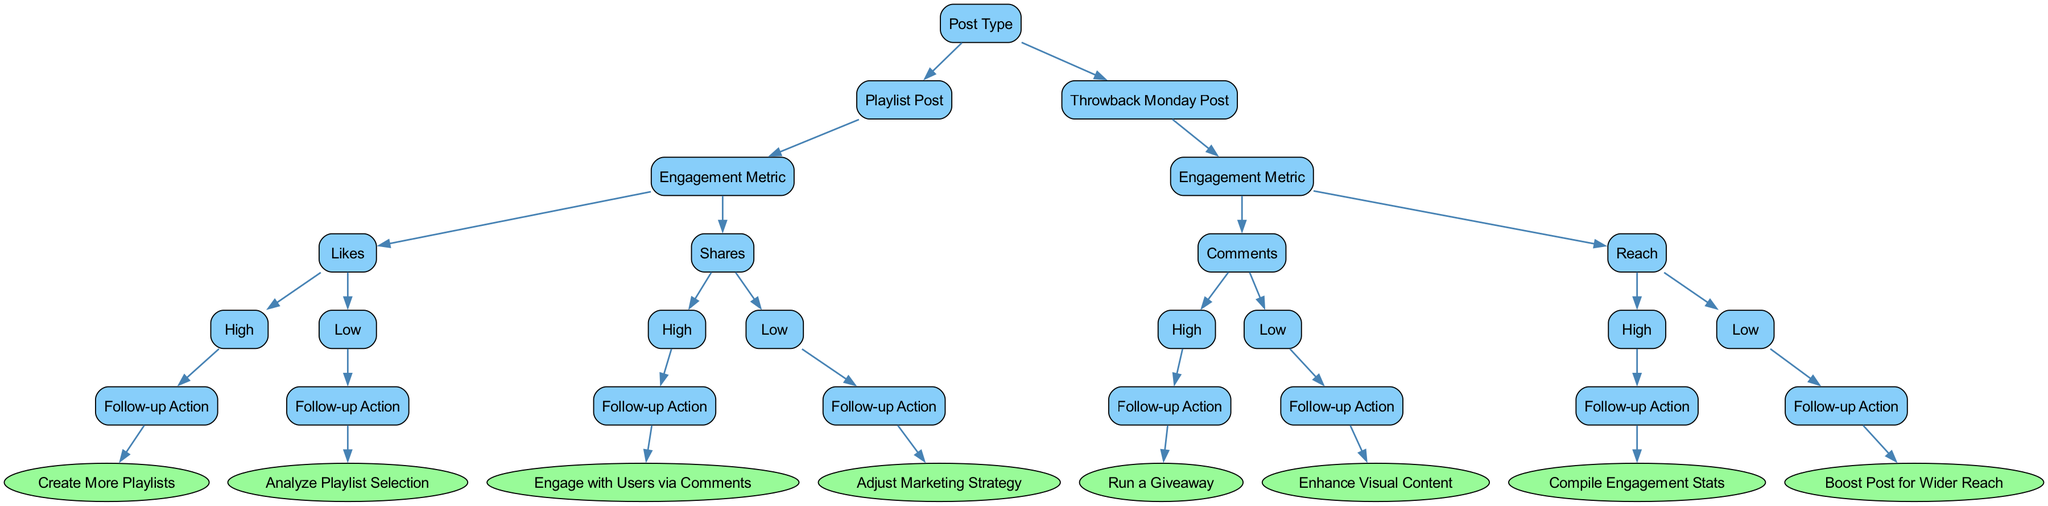What is the root node of the decision tree? The root node is labeled "Post Type", which is the starting point of the tree and categorizes the subsequent decisions based on post types.
Answer: Post Type How many children does the node "Playlist Post" have? The "Playlist Post" node has two children: "Engagement Metric" and "Throwback Monday Post". Each child represents a separate aspect of engagement.
Answer: 2 What follow-up action is suggested when "Likes" are classified as "Low"? When "Likes" are classified as "Low", the suggested follow-up action is to "Analyze Playlist Selection" to understand how to improve engagement.
Answer: Analyze Playlist Selection If "Comments" are classified as "High" for a "Throwback Monday Post", what is the recommended follow-up action? The follow-up action when "Comments" are classified as "High" is to "Run a Giveaway", utilizing the high engagement to further increase interaction.
Answer: Run a Giveaway What is the final action recommended when "Shares" are classified as "High"? The final action when "Shares" are classified as "High" is to "Engage with Users via Comments", fostering community interaction based on successful content.
Answer: Engage with Users via Comments If the engagement metric "Reach" is "Low", what is the suggested action? If "Reach" is "Low", the suggested action is to "Boost Post for Wider Reach", which aims to increase visibility and interaction.
Answer: Boost Post for Wider Reach What are the two engagement metrics assessed under "Playlist Post"? The two engagement metrics under "Playlist Post" are "Likes" and "Shares", which measure the post's performance and audience interaction.
Answer: Likes and Shares What is the relationship between "High" Likes and the follow-up action? The relationship is that "High" Likes lead to the follow-up action of "Create More Playlists", indicating a positive response from the audience encouraging continued content creation.
Answer: Create More Playlists What is the purpose of the "Engagement Metric" node in the decision tree? The purpose of the "Engagement Metric" node is to categorize and assess different metrics like Likes, Shares, Comments, and Reach to inform follow-up actions based on their performance.
Answer: To assess metrics for follow-up actions 